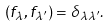Convert formula to latex. <formula><loc_0><loc_0><loc_500><loc_500>\left ( f _ { \lambda } , f _ { \lambda ^ { \prime } } \right ) = \delta _ { \lambda \lambda ^ { \prime } } .</formula> 